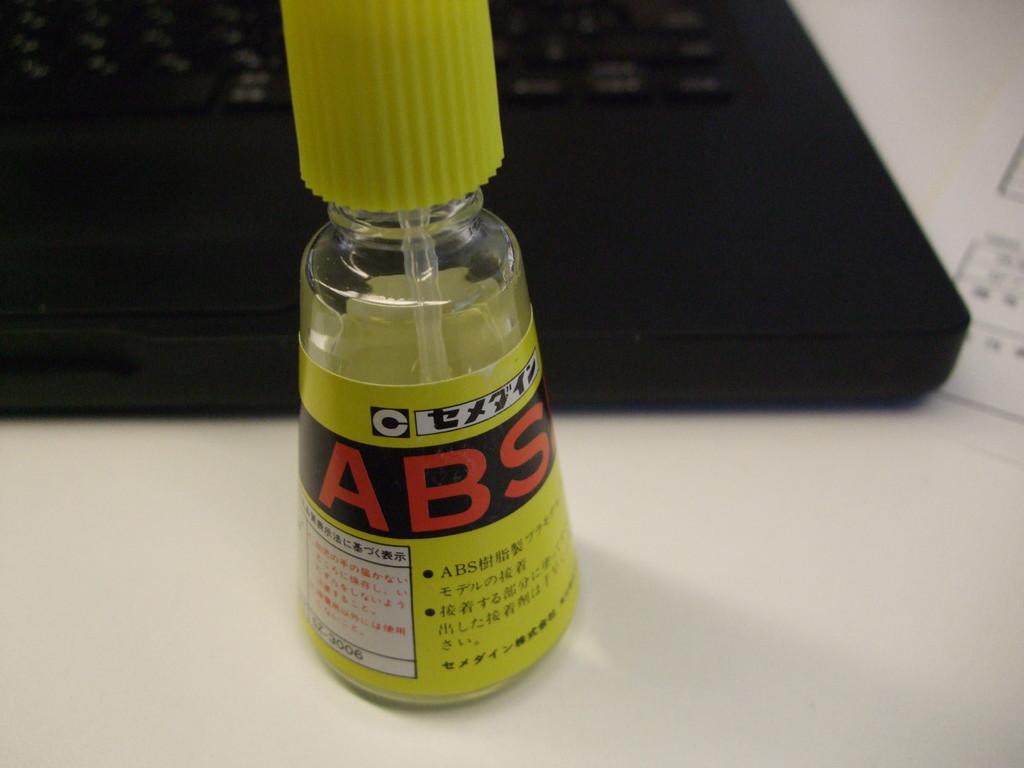What is that glue?
Keep it short and to the point. Abs. 